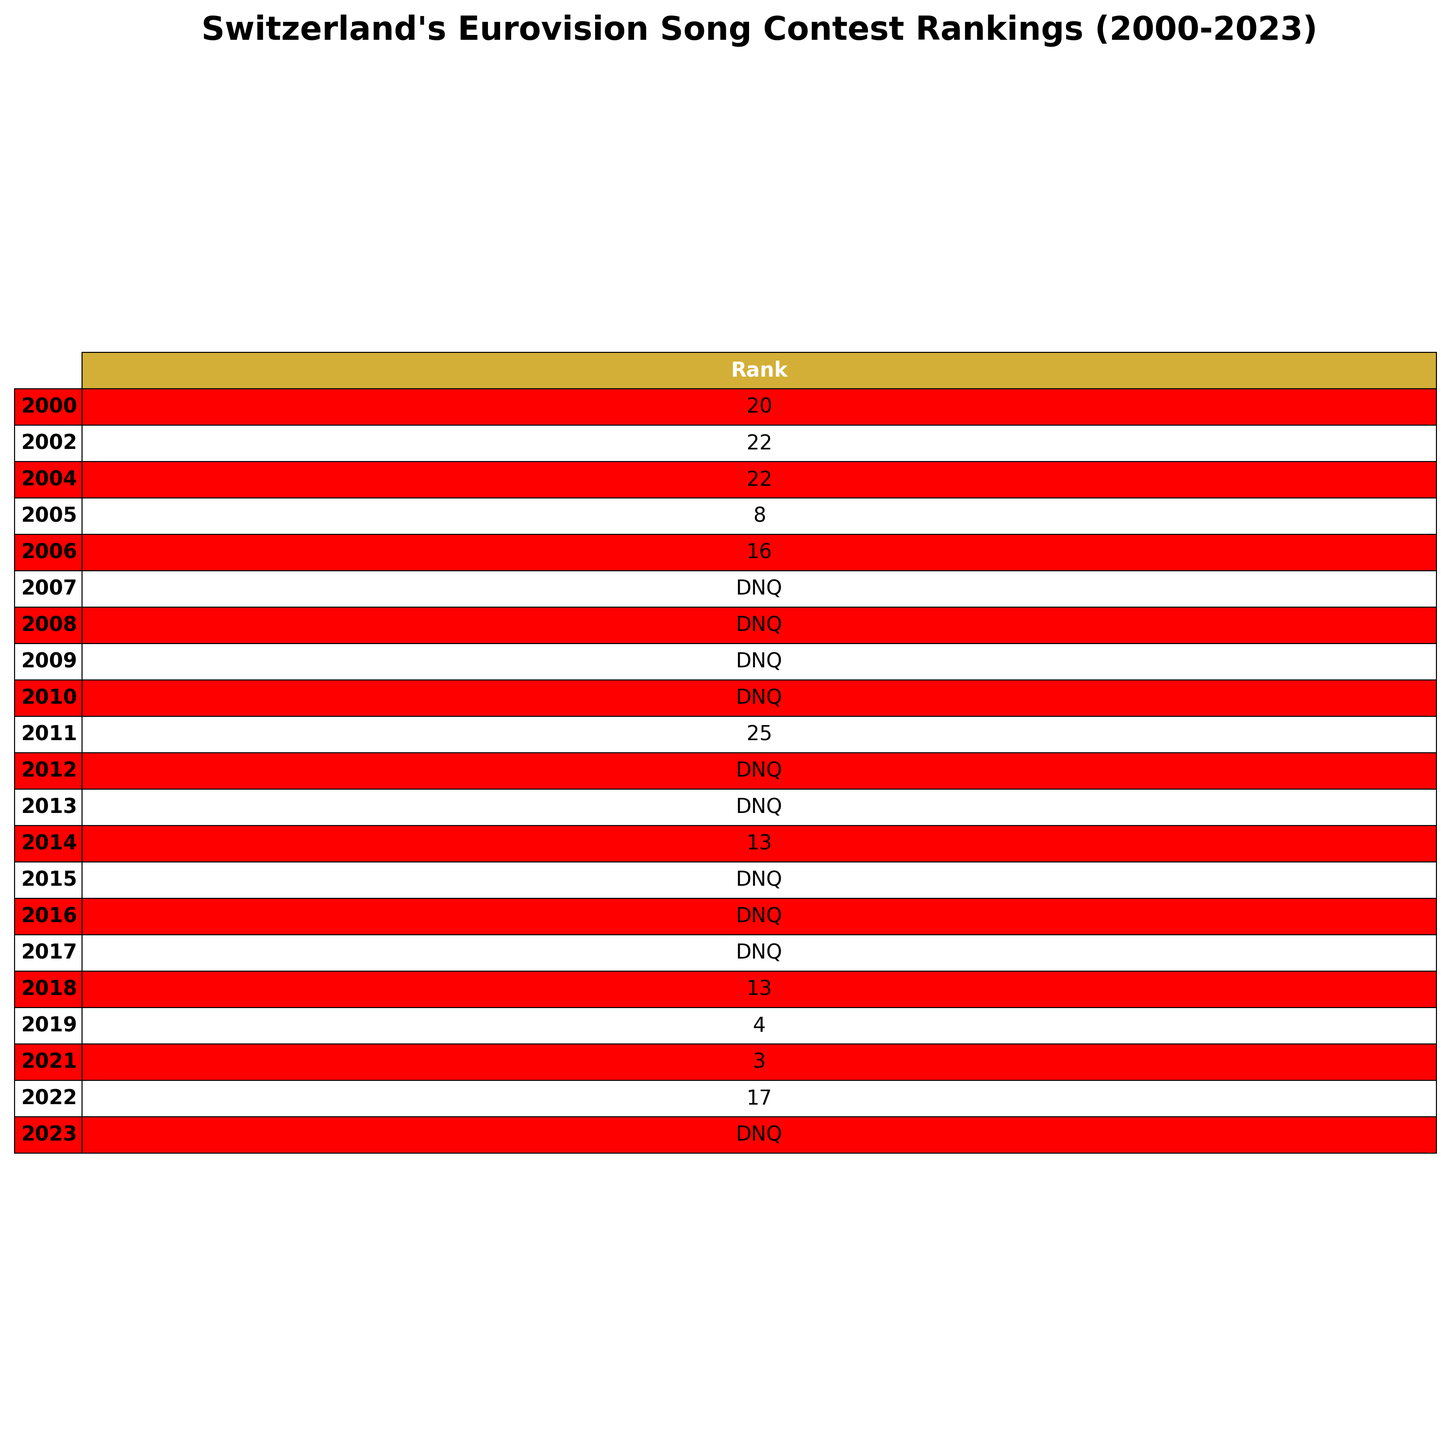What was Switzerland's rank in 2021? The table shows that in the year 2021, Switzerland ranked 3rd in the Eurovision Song Contest.
Answer: 3 How many times did Switzerland not qualify for the Eurovision Song Contest from 2000 to 2023? The table reveals that Switzerland did not qualify in the years 2007, 2008, 2009, 2010, 2012, 2013, 2015, 2016, 2017, and 2023, totaling 10 instances.
Answer: 10 What is the average rank of Switzerland from 2000 to 2023, excluding the disqualifications? The ranks for qualifying years are 20, 22, 22, 8, 16, 25, 13, 13, 4, 3, and 17. There are 11 qualifying entries, which sum up to 20 + 22 + 22 + 8 + 16 + 25 + 13 + 13 + 4 + 3 + 17 =  193, and the average is 193 / 11 ≈ 17.55.
Answer: Approximately 17.5 What was Switzerland's highest rank in the Eurovision Song Contest since 2000? The highest rank shown in the table is 3rd, which Switzerland achieved in the years 2021.
Answer: 3 Which year did Switzerland achieve their best rank in the Eurovision Song Contest? By checking the ranks, Switzerland's best rank was achieved in 2021, which is 3rd place.
Answer: 2021 Was there any year where Switzerland ranked higher than 8th place? Looking through the table, Switzerland never ranked higher than 8th place except for two instances: 4th in 2019 and 3rd in 2021. Thus, the answer is yes.
Answer: Yes What rank did Switzerland achieve in 2019, and how does that compare to their rank in 2022? In 2019, Switzerland ranked 4th, while in 2022, the rank was 17. Thus, the rank in 2019 was significantly higher than in 2022.
Answer: 4th in 2019, 17th in 2022 Was the rank of Switzerland in 2022 better than their rank in 2011? The table shows Switzerland ranked 17th in 2022 and 25th in 2011, so the 2022 rank is indeed better.
Answer: Yes What percentage of the years from 2000 to 2023 did Switzerland finish in the top 10? Switzerland finished in the top 10 in 2005, 4th in 2019, and 3rd in 2021, which makes 3 instances out of 24 years (from 2000 to 2023 inclusive). Therefore, the percentage is (3/24) * 100 = 12.5%.
Answer: 12.5% In how many consecutive years from 2000 to 2023 did Switzerland fail to qualify for the contest? The table shows that Switzerland failed to qualify for 10 years, with a continuous stretch from 2007 to 2017 inclusive, totaling 11 years.
Answer: 11 years 